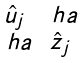<formula> <loc_0><loc_0><loc_500><loc_500>\begin{smallmatrix} \hat { u } _ { j } & \ h a \\ \ h a & \hat { z } _ { j } \end{smallmatrix}</formula> 